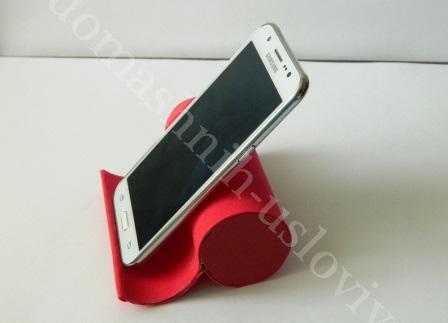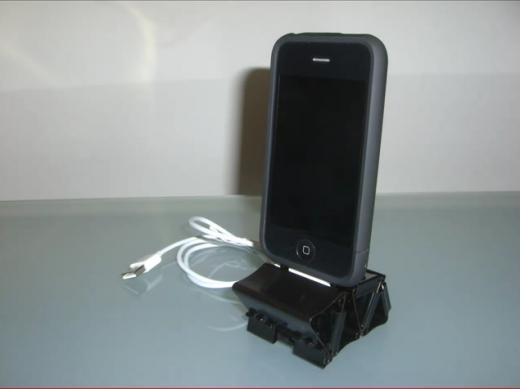The first image is the image on the left, the second image is the image on the right. For the images shown, is this caption "At least one cell phone is on a stand facing left." true? Answer yes or no. Yes. 